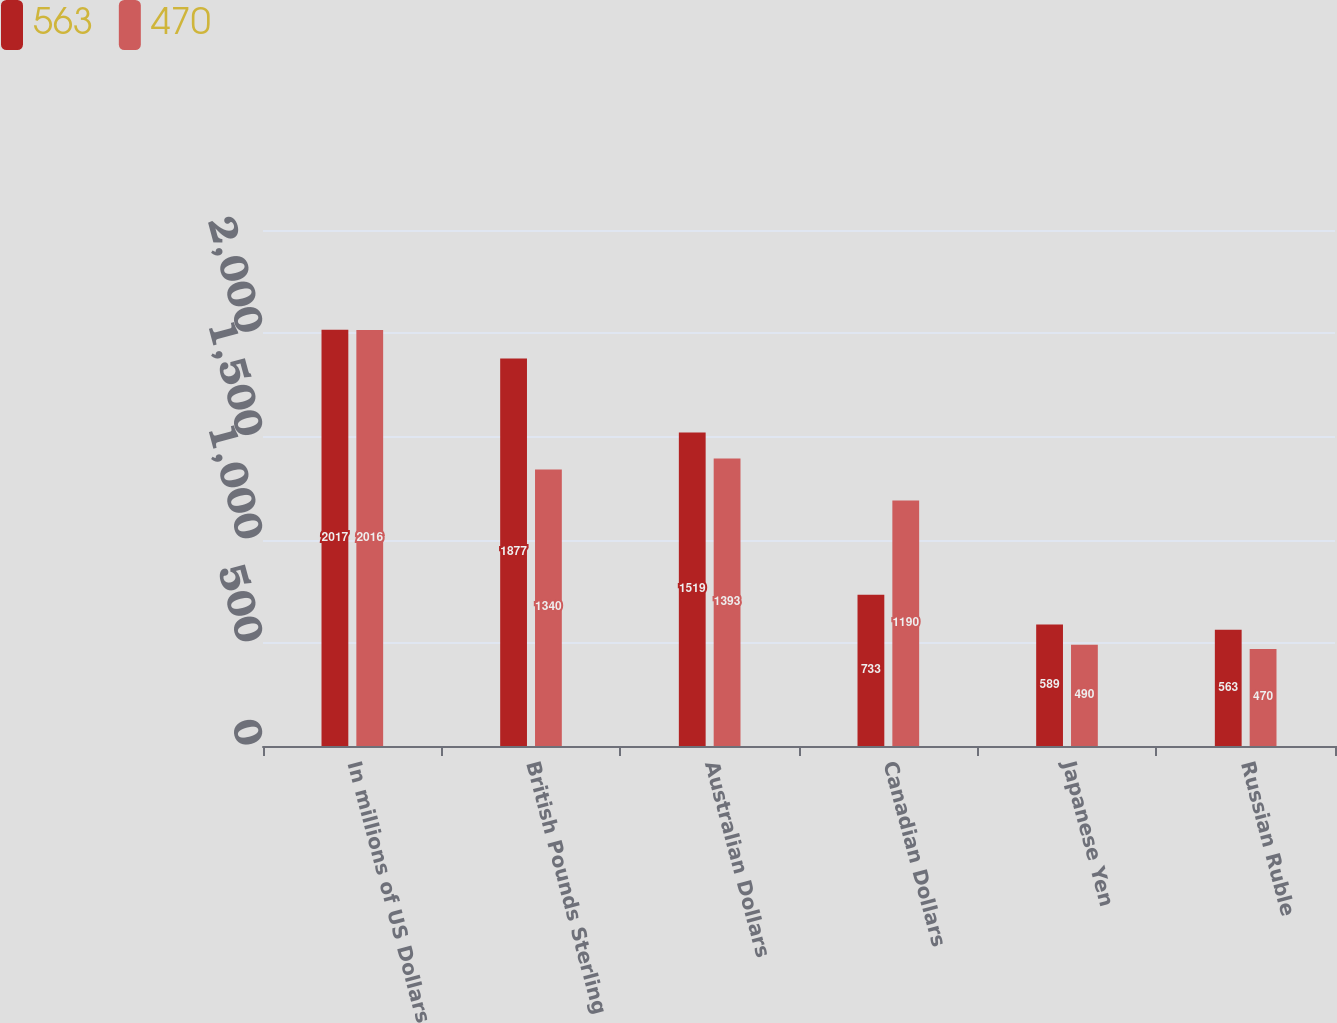<chart> <loc_0><loc_0><loc_500><loc_500><stacked_bar_chart><ecel><fcel>In millions of US Dollars<fcel>British Pounds Sterling<fcel>Australian Dollars<fcel>Canadian Dollars<fcel>Japanese Yen<fcel>Russian Ruble<nl><fcel>563<fcel>2017<fcel>1877<fcel>1519<fcel>733<fcel>589<fcel>563<nl><fcel>470<fcel>2016<fcel>1340<fcel>1393<fcel>1190<fcel>490<fcel>470<nl></chart> 